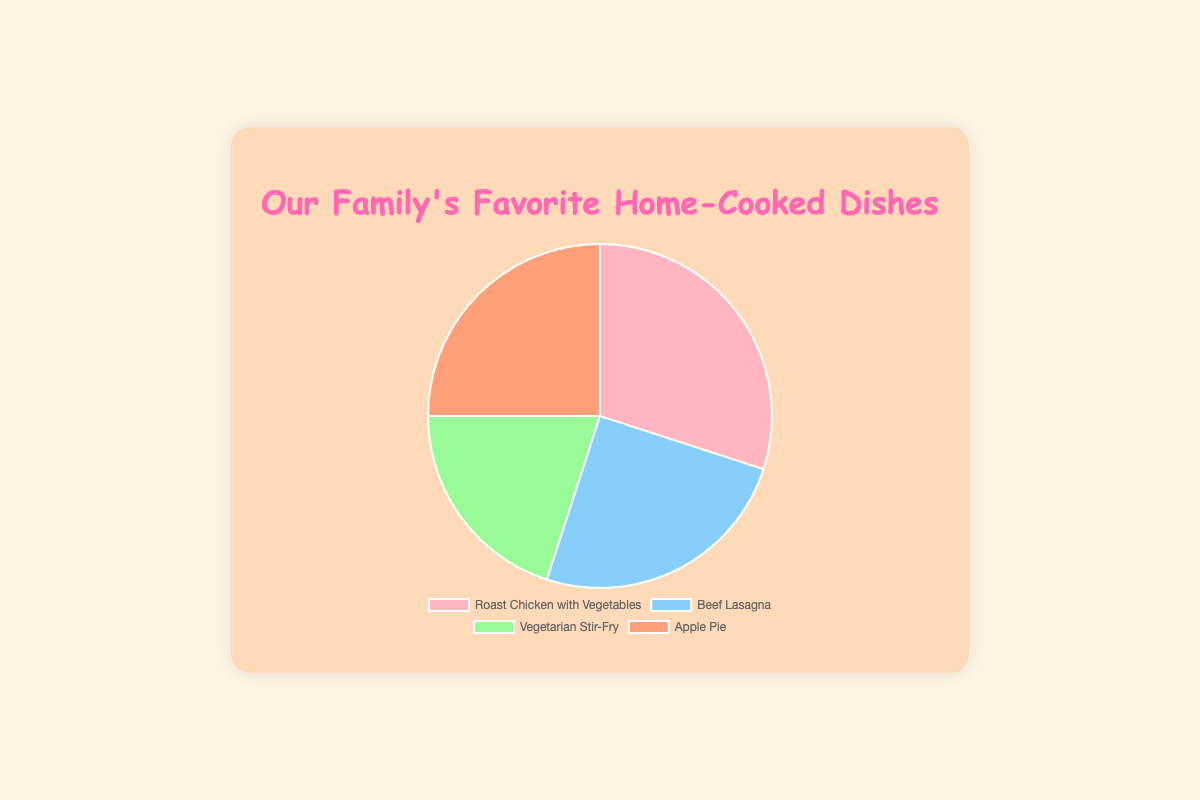What percentage of the family prefers Roast Chicken with Vegetables? The figure shows that 30% of the family prefers Roast Chicken with Vegetables as indicated in the pie chart.
Answer: 30% What is the combined percentage of family members who favor Beef Lasagna and Apple Pie? To find the combined percentage, add the percentages of the family members who favor Beef Lasagna and Apple Pie. The percentages are 25% for Beef Lasagna and 25% for Apple Pie. So, 25% + 25% = 50%.
Answer: 50% Which dish has the smallest share of preferences at family gatherings? The dish with the smallest share of preferences is Vegetarian Stir-Fry, which has a 20% share according to the pie chart.
Answer: Vegetarian Stir-Fry How does the preference for Vegetarian Stir-Fry compare to the preference for Beef Lasagna? To compare the preferences, we look at the percentages. Vegetarian Stir-Fry has 20% and Beef Lasagna has 25%. Therefore, Beef Lasagna is preferred more than Vegetarian Stir-Fry by 5%.
Answer: Beef Lasagna is preferred by 5% more What are the colors representing Roast Chicken with Vegetables and Apple Pie in the pie chart? The colors representing Roast Chicken with Vegetables and Apple Pie in the pie chart are pink and orange, respectively.
Answer: Pink and Orange If we combine the percentages of the most and least preferred dishes, what would the total be? The most preferred dish is Roast Chicken with Vegetables at 30% and the least preferred is Vegetarian Stir-Fry at 20%. Adding these gives 30% + 20% = 50%.
Answer: 50% How do the preferences for Roast Chicken with Vegetables and Apple Pie visually compare on the pie chart? Both Roast Chicken with Vegetables and Apple Pie have similar-sized sections in the pie chart, each occupying a large segment since they both have comparable percentages of 30% and 25%, respectively.
Answer: Similar-sized segments What is the average percentage preference for all the dishes at family gatherings? The average percentage is calculated by summing all percentage preferences and dividing by the number of dishes. (30% + 25% + 20% + 25%) / 4 = 100% / 4 = 25%.
Answer: 25% If the percentage for Beef Lasagna increased by 5%, which other dish would it then be equal to? Increasing the percentage for Beef Lasagna by 5% gives 25% + 5% = 30%. This would make it equal to Roast Chicken with Vegetables, which is at 30%.
Answer: Roast Chicken with Vegetables 